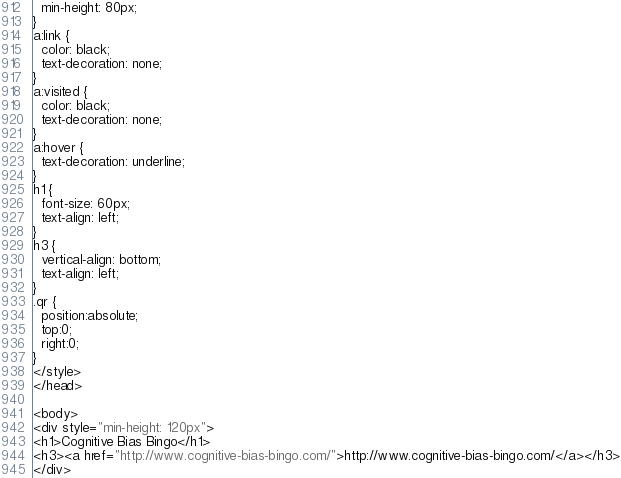Convert code to text. <code><loc_0><loc_0><loc_500><loc_500><_HTML_>  min-height: 80px;
}
a:link {
  color: black;
  text-decoration: none;
}
a:visited {
  color: black;
  text-decoration: none;
}
a:hover {
  text-decoration: underline;
}
h1 {
  font-size: 60px;
  text-align: left;
}
h3 {
  vertical-align: bottom;
  text-align: left;
}
.qr {
  position:absolute;
  top:0;
  right:0;
}
</style>
</head>

<body>
<div style="min-height: 120px">
<h1>Cognitive Bias Bingo</h1>
<h3><a href="http://www.cognitive-bias-bingo.com/">http://www.cognitive-bias-bingo.com/</a></h3>
</div></code> 